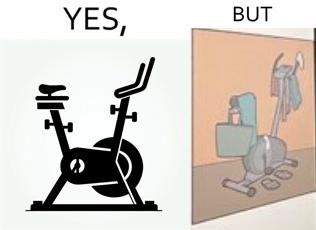Provide a description of this image. This is a satirical image with contrasting elements. 